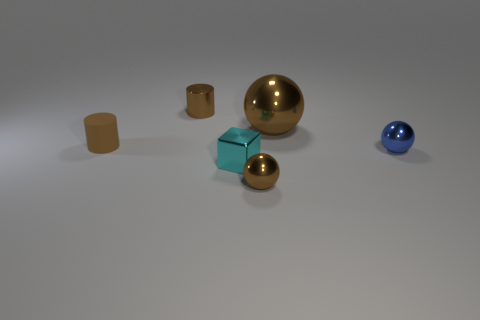What number of metal things are behind the small block and to the right of the small brown metal cylinder?
Give a very brief answer. 2. There is a brown matte thing that is the same size as the blue thing; what is its shape?
Provide a short and direct response. Cylinder. There is a brown object that is in front of the tiny rubber cylinder in front of the object that is behind the large brown object; what is its material?
Provide a short and direct response. Metal. The small cylinder that is made of the same material as the cyan cube is what color?
Your response must be concise. Brown. What number of balls are to the left of the shiny sphere that is in front of the tiny shiny ball that is behind the tiny brown ball?
Provide a short and direct response. 0. What is the material of the cylinder that is the same color as the rubber thing?
Offer a terse response. Metal. Is there anything else that has the same shape as the cyan metallic object?
Provide a succinct answer. No. What number of objects are either cylinders to the right of the matte object or big brown cubes?
Your answer should be very brief. 1. There is a small cylinder in front of the metallic cylinder; does it have the same color as the tiny metal cylinder?
Give a very brief answer. Yes. What is the shape of the tiny blue metallic object to the right of the small cylinder in front of the small metallic cylinder?
Provide a succinct answer. Sphere. 